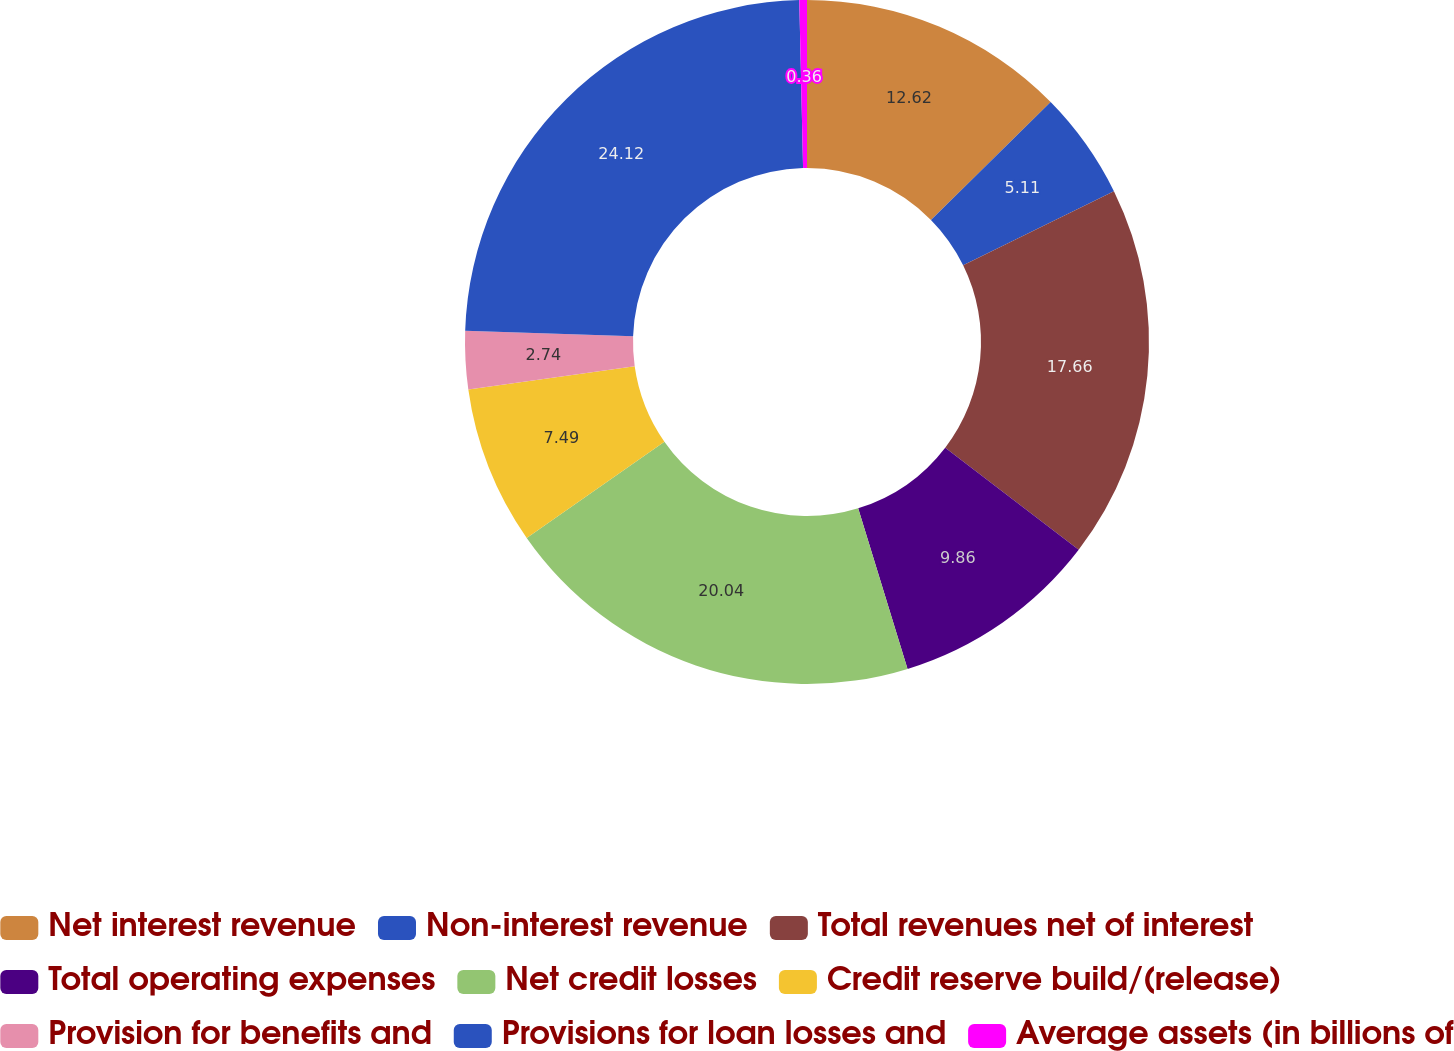Convert chart to OTSL. <chart><loc_0><loc_0><loc_500><loc_500><pie_chart><fcel>Net interest revenue<fcel>Non-interest revenue<fcel>Total revenues net of interest<fcel>Total operating expenses<fcel>Net credit losses<fcel>Credit reserve build/(release)<fcel>Provision for benefits and<fcel>Provisions for loan losses and<fcel>Average assets (in billions of<nl><fcel>12.62%<fcel>5.11%<fcel>17.66%<fcel>9.86%<fcel>20.04%<fcel>7.49%<fcel>2.74%<fcel>24.12%<fcel>0.36%<nl></chart> 